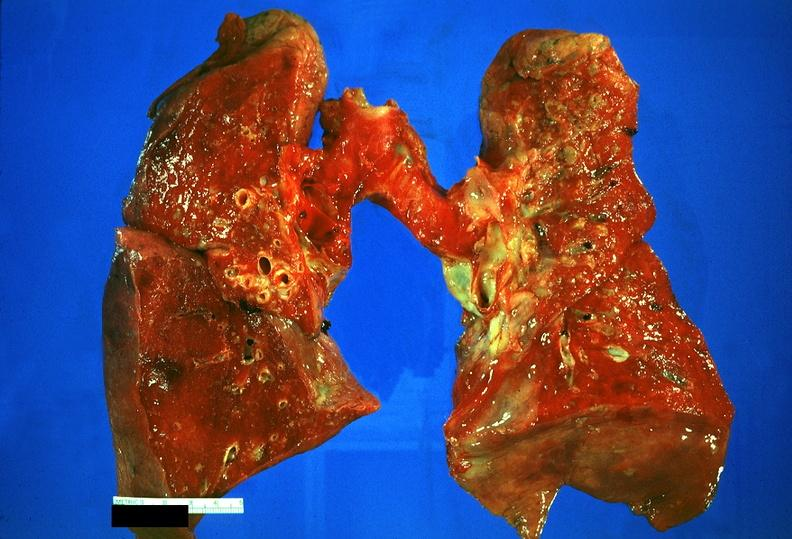does malignant adenoma show lung, sarcoidosis?
Answer the question using a single word or phrase. No 